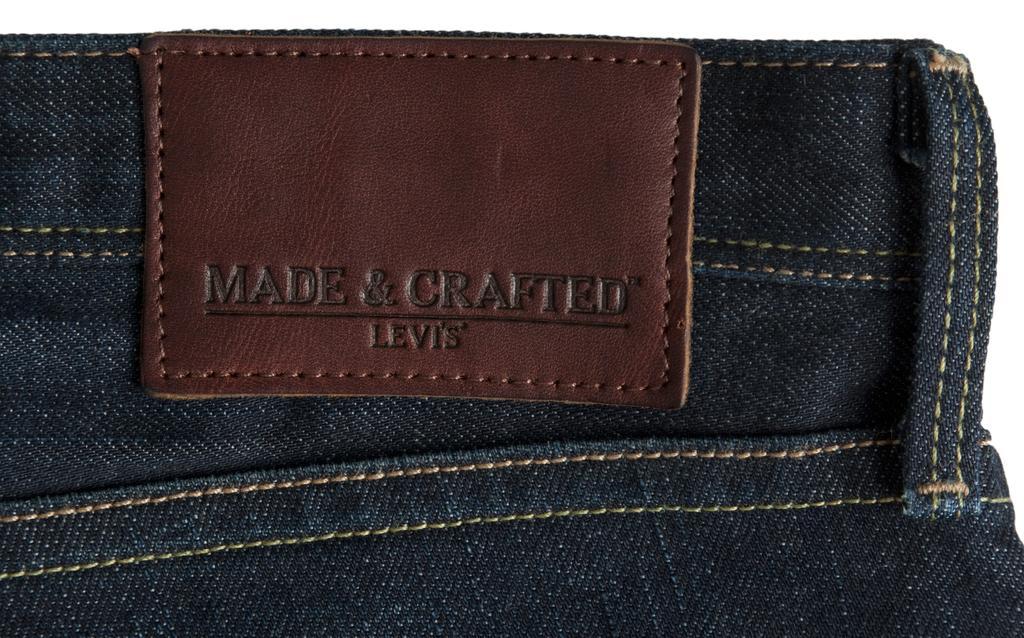Describe this image in one or two sentences. In the image we can see the jeans cloth, on it there is a tag and text on the tag. 